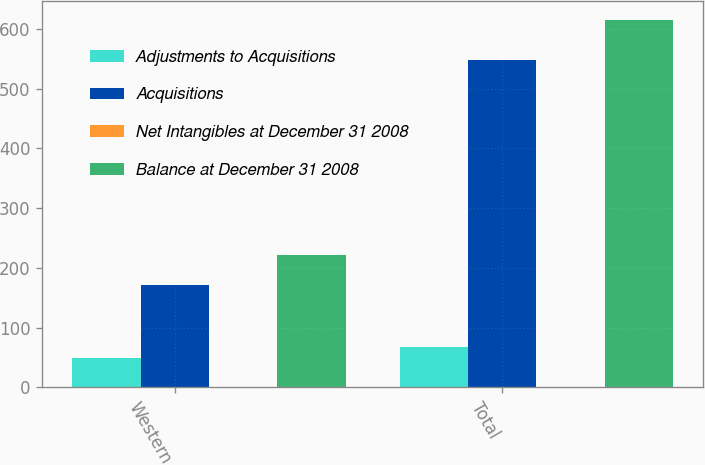<chart> <loc_0><loc_0><loc_500><loc_500><stacked_bar_chart><ecel><fcel>Western<fcel>Total<nl><fcel>Adjustments to Acquisitions<fcel>49.6<fcel>67.3<nl><fcel>Acquisitions<fcel>170.9<fcel>547.9<nl><fcel>Net Intangibles at December 31 2008<fcel>0.2<fcel>0.2<nl><fcel>Balance at December 31 2008<fcel>220.7<fcel>615.4<nl></chart> 